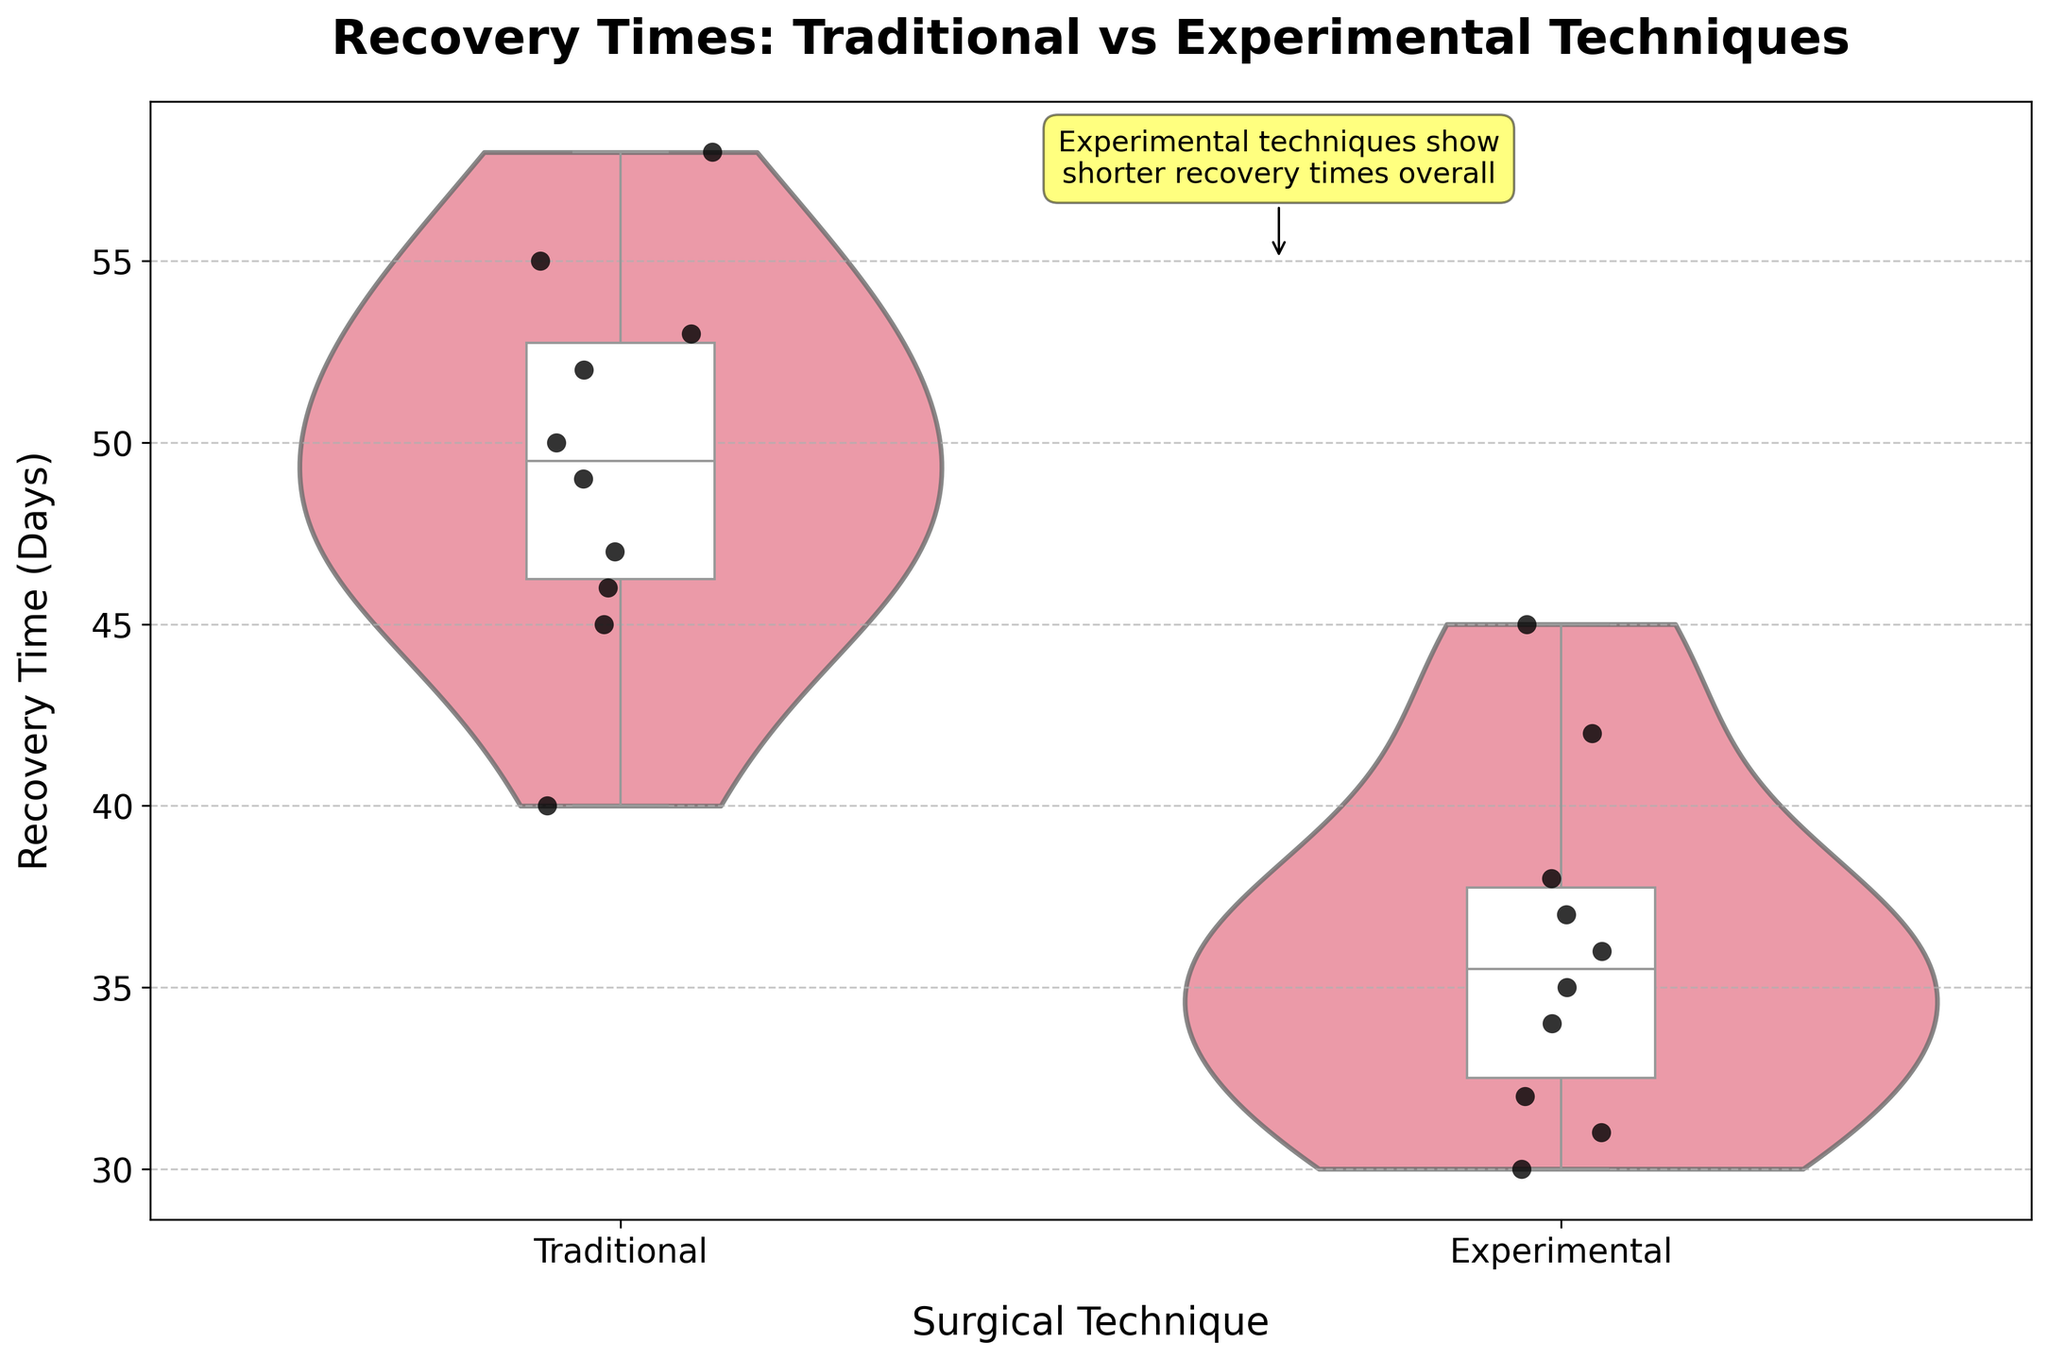What is the title of the figure? The title is placed at the top of the figure and states the main comparison being shown.
Answer: Recovery Times: Traditional vs Experimental Techniques What are the names of the two surgical techniques represented? The text on the x-axis shows the names of the techniques being compared.
Answer: Traditional and Experimental Which technique shows a lower median recovery time? The box plot within the Violin Chart shows the median as the line within the box. The Experimental technique's median line is lower.
Answer: Experimental What is the approximate range of recovery times for the Experimental technique? The Violin Plot and Box Plot together indicate the spread of data points; for the Experimental technique, recovery times range from about 30 to 45 days.
Answer: 30 to 45 days Which technique has a wider distribution of recovery times? The width and spread of the Violin Plot give an indication of the distribution. The Traditional technique has a wider distribution compared to the Experimental technique.
Answer: Traditional How do the quartile ranges of the techniques compare? The width of the boxes in the Box Plot indicates the interquartile range (IQR); the IQR for the Traditional technique is wider than that of the Experimental technique. The edges of the boxes and whiskers show these ranges clearly.
Answer: Traditional has a wider IQR What can be said about the presence of outliers for both techniques? Outliers are usually shown as individual points outside the whiskers in a Box Plot. In this plot, no outliers are shown as the strip plot does not highlight any isolated points far outside the whisker range.
Answer: No outliers What does the annotation in the figure suggest? Annotations are text within the figure box. Here, it suggests that the Experimental techniques show shorter recovery times overall.
Answer: Experimental techniques show shorter recovery times Compare the densest recovery times for both techniques. The Violin Plot's width represents density. The densest part for the Traditional technique is around 45-50 days, and for the Experimental technique, it is around 30-35 days.
Answer: Traditional: 45-50 days, Experimental: 30-35 days What details can you infer about recovery times based on the strip plots? Strip plots show individual data points. For the Traditional technique, most points cluster around 45-55 days, while for Experimental, they cluster around 30-40 days, with fewer overlaps compared to the Traditional technique.
Answer: Traditional: 45-55 days, Experimental: 30-40 days 